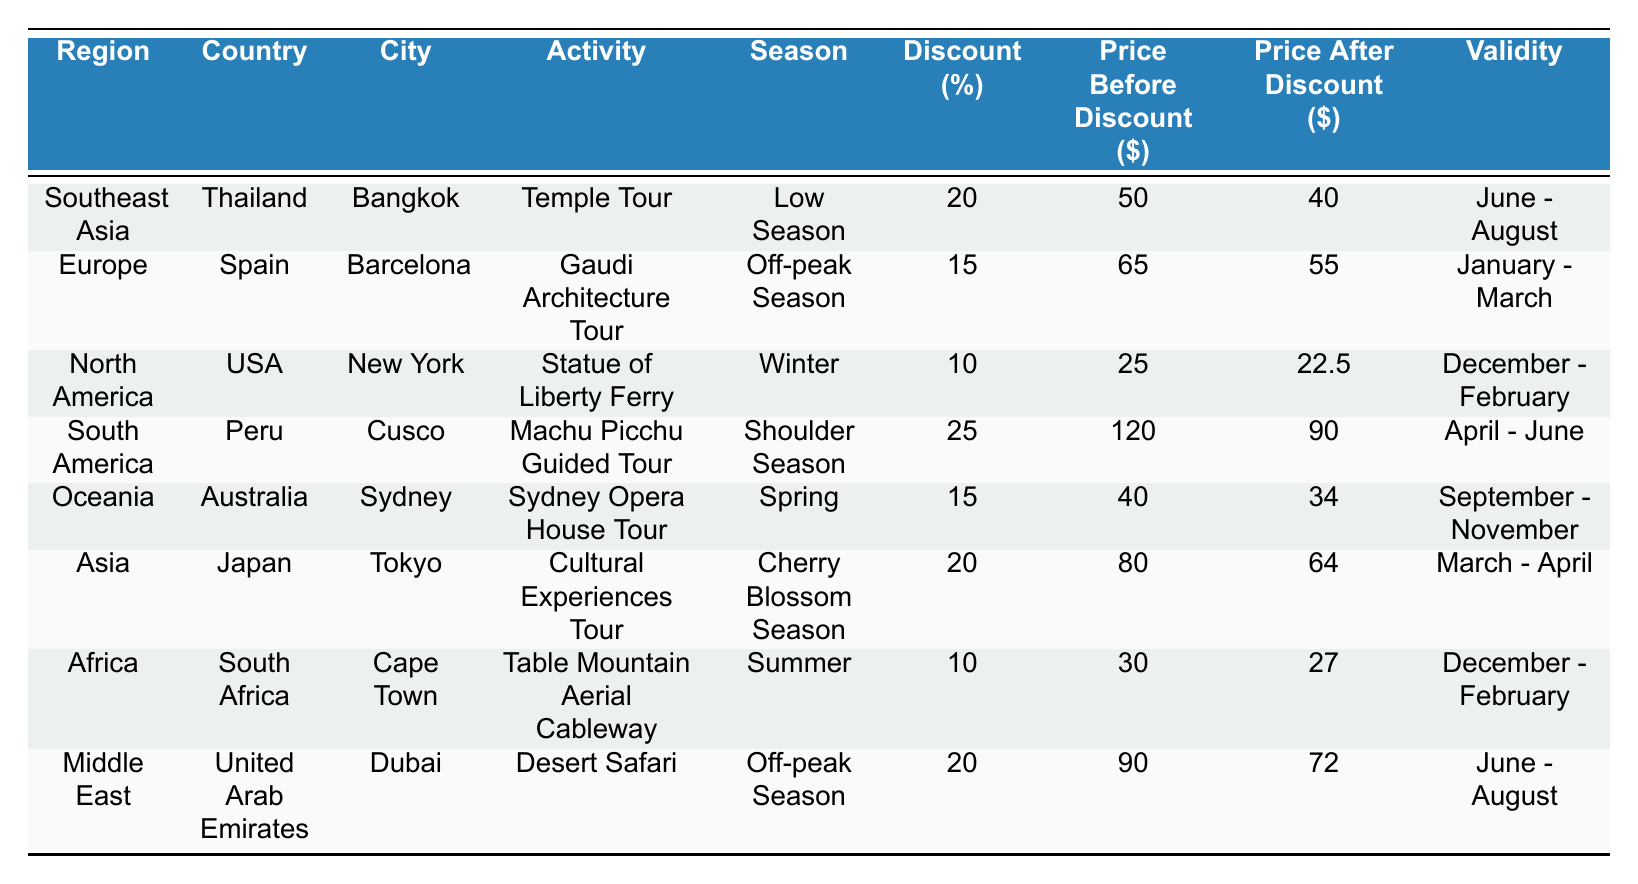What is the discount percentage for the Machu Picchu Guided Tour in Cusco? The table indicates that the discount percentage for the Machu Picchu Guided Tour listed under "South America" and "Cusco" is 25%.
Answer: 25% Which city offers a Temple Tour at a price of $40 after discount? According to the table, the city of Bangkok in Thailand offers a Temple Tour at a price of $40 after a discount.
Answer: Bangkok Is the Sydney Opera House Tour available during the winter season? The table shows that the Sydney Opera House Tour is scheduled during the Spring season, specifically from September to November, so it is not available in winter.
Answer: No What is the price difference before and after the discount for the Gaudi Architecture Tour? The price before the discount for the Gaudi Architecture Tour is $65 and after the discount, it is $55. The price difference is calculated as $65 - $55 = $10.
Answer: $10 Which region has the highest discount percentage listed, and what is that percentage? Upon reviewing the table, the South America region has the highest discount percentage at 25% for the Machu Picchu Guided Tour.
Answer: 25% How much would one save on the Desert Safari if purchased during the off-peak season? The original price of the Desert Safari is $90, and after a 20% discount, the price becomes $72. The savings can be calculated as $90 - $72 = $18.
Answer: $18 In which months is the price after discount for the Cultural Experiences Tour valid? The Cultural Experiences Tour's discounted price of $64 is valid during the months of March to April.
Answer: March - April What is the average discount percentage of all activities listed in the table? To find the average discount percentage, add all the percentages (20 + 15 + 10 + 25 + 15 + 20 + 10 + 20 = 125) and divide by the number of activities (8), which equals 15.625%.
Answer: 15.625% Is the price after discount for the Table Mountain Aerial Cableway less than $30? The table shows the price after discount for the Table Mountain Aerial Cableway is $27, which is indeed less than $30.
Answer: Yes Identify the activities that have a discount of 20% or more. The activities with a discount of 20% or more are the Temple Tour (20%), Machu Picchu Guided Tour (25%), and the Cultural Experiences Tour (20%).
Answer: Temple Tour, Machu Picchu Guided Tour, Cultural Experiences Tour 